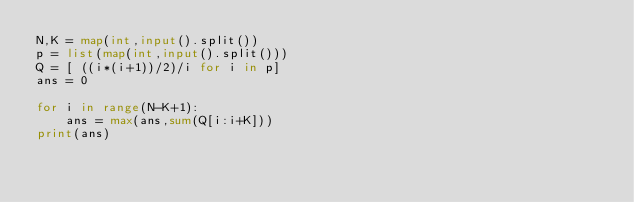Convert code to text. <code><loc_0><loc_0><loc_500><loc_500><_Python_>N,K = map(int,input().split())
p = list(map(int,input().split()))
Q = [ ((i*(i+1))/2)/i for i in p]
ans = 0

for i in range(N-K+1):
    ans = max(ans,sum(Q[i:i+K]))
print(ans)
</code> 